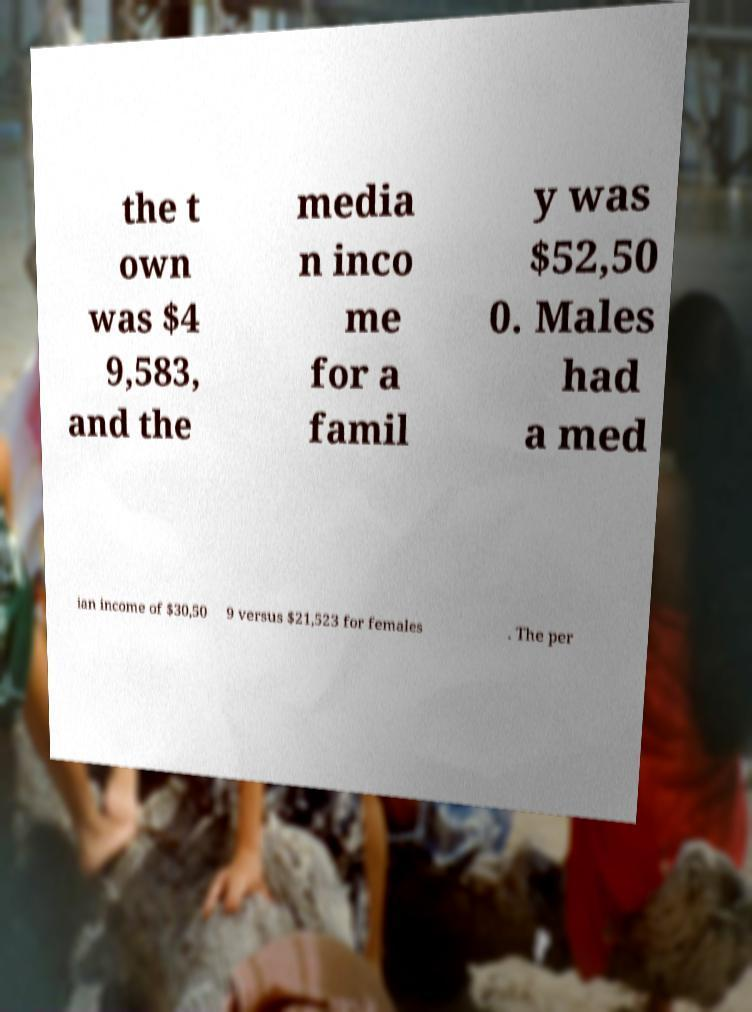What messages or text are displayed in this image? I need them in a readable, typed format. the t own was $4 9,583, and the media n inco me for a famil y was $52,50 0. Males had a med ian income of $30,50 9 versus $21,523 for females . The per 